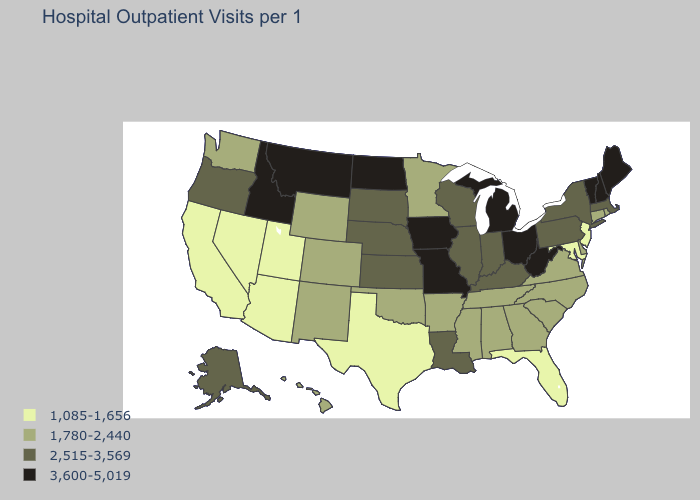Does North Carolina have the lowest value in the South?
Short answer required. No. What is the lowest value in states that border Utah?
Concise answer only. 1,085-1,656. Name the states that have a value in the range 1,085-1,656?
Concise answer only. Arizona, California, Florida, Maryland, Nevada, New Jersey, Texas, Utah. Which states have the lowest value in the USA?
Concise answer only. Arizona, California, Florida, Maryland, Nevada, New Jersey, Texas, Utah. Name the states that have a value in the range 1,085-1,656?
Write a very short answer. Arizona, California, Florida, Maryland, Nevada, New Jersey, Texas, Utah. Name the states that have a value in the range 1,780-2,440?
Write a very short answer. Alabama, Arkansas, Colorado, Connecticut, Delaware, Georgia, Hawaii, Minnesota, Mississippi, New Mexico, North Carolina, Oklahoma, Rhode Island, South Carolina, Tennessee, Virginia, Washington, Wyoming. Among the states that border Oklahoma , does Texas have the highest value?
Concise answer only. No. What is the value of Rhode Island?
Quick response, please. 1,780-2,440. Among the states that border Oregon , does Idaho have the highest value?
Quick response, please. Yes. Name the states that have a value in the range 3,600-5,019?
Give a very brief answer. Idaho, Iowa, Maine, Michigan, Missouri, Montana, New Hampshire, North Dakota, Ohio, Vermont, West Virginia. Among the states that border Nevada , which have the highest value?
Keep it brief. Idaho. Name the states that have a value in the range 2,515-3,569?
Give a very brief answer. Alaska, Illinois, Indiana, Kansas, Kentucky, Louisiana, Massachusetts, Nebraska, New York, Oregon, Pennsylvania, South Dakota, Wisconsin. Name the states that have a value in the range 1,780-2,440?
Concise answer only. Alabama, Arkansas, Colorado, Connecticut, Delaware, Georgia, Hawaii, Minnesota, Mississippi, New Mexico, North Carolina, Oklahoma, Rhode Island, South Carolina, Tennessee, Virginia, Washington, Wyoming. What is the value of Georgia?
Keep it brief. 1,780-2,440. What is the value of Oklahoma?
Write a very short answer. 1,780-2,440. 